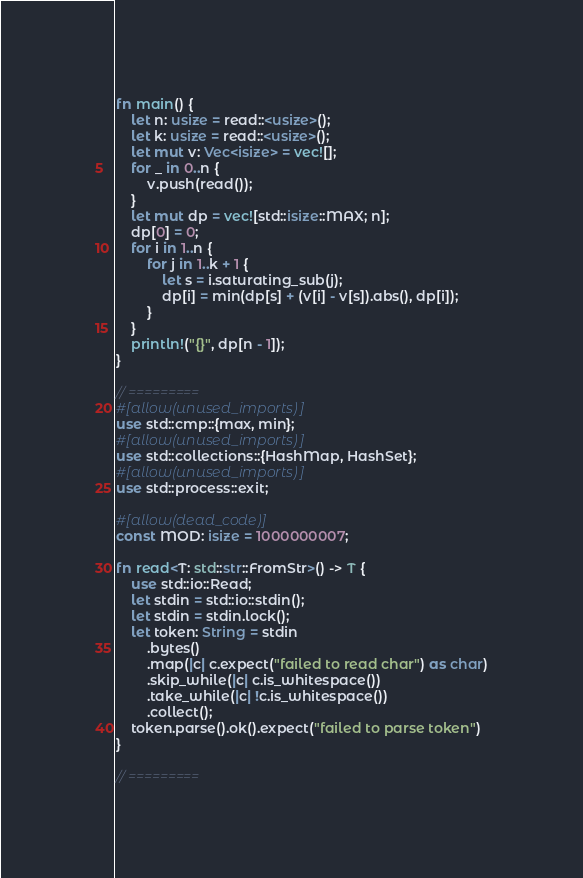<code> <loc_0><loc_0><loc_500><loc_500><_Rust_>fn main() {
    let n: usize = read::<usize>();
    let k: usize = read::<usize>();
    let mut v: Vec<isize> = vec![];
    for _ in 0..n {
        v.push(read());
    }
    let mut dp = vec![std::isize::MAX; n];
    dp[0] = 0;
    for i in 1..n {
        for j in 1..k + 1 {
            let s = i.saturating_sub(j);
            dp[i] = min(dp[s] + (v[i] - v[s]).abs(), dp[i]);
        }
    }
    println!("{}", dp[n - 1]);
}

// =========
#[allow(unused_imports)]
use std::cmp::{max, min};
#[allow(unused_imports)]
use std::collections::{HashMap, HashSet};
#[allow(unused_imports)]
use std::process::exit;

#[allow(dead_code)]
const MOD: isize = 1000000007;

fn read<T: std::str::FromStr>() -> T {
    use std::io::Read;
    let stdin = std::io::stdin();
    let stdin = stdin.lock();
    let token: String = stdin
        .bytes()
        .map(|c| c.expect("failed to read char") as char)
        .skip_while(|c| c.is_whitespace())
        .take_while(|c| !c.is_whitespace())
        .collect();
    token.parse().ok().expect("failed to parse token")
}

// =========
</code> 